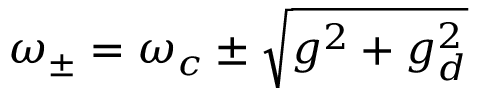<formula> <loc_0><loc_0><loc_500><loc_500>\omega _ { \pm } = \omega _ { c } \pm \sqrt { g ^ { 2 } + g _ { d } ^ { 2 } }</formula> 